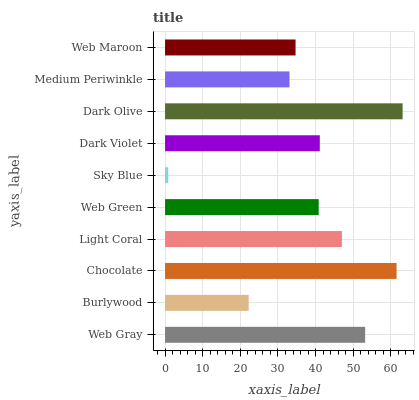Is Sky Blue the minimum?
Answer yes or no. Yes. Is Dark Olive the maximum?
Answer yes or no. Yes. Is Burlywood the minimum?
Answer yes or no. No. Is Burlywood the maximum?
Answer yes or no. No. Is Web Gray greater than Burlywood?
Answer yes or no. Yes. Is Burlywood less than Web Gray?
Answer yes or no. Yes. Is Burlywood greater than Web Gray?
Answer yes or no. No. Is Web Gray less than Burlywood?
Answer yes or no. No. Is Dark Violet the high median?
Answer yes or no. Yes. Is Web Green the low median?
Answer yes or no. Yes. Is Chocolate the high median?
Answer yes or no. No. Is Medium Periwinkle the low median?
Answer yes or no. No. 